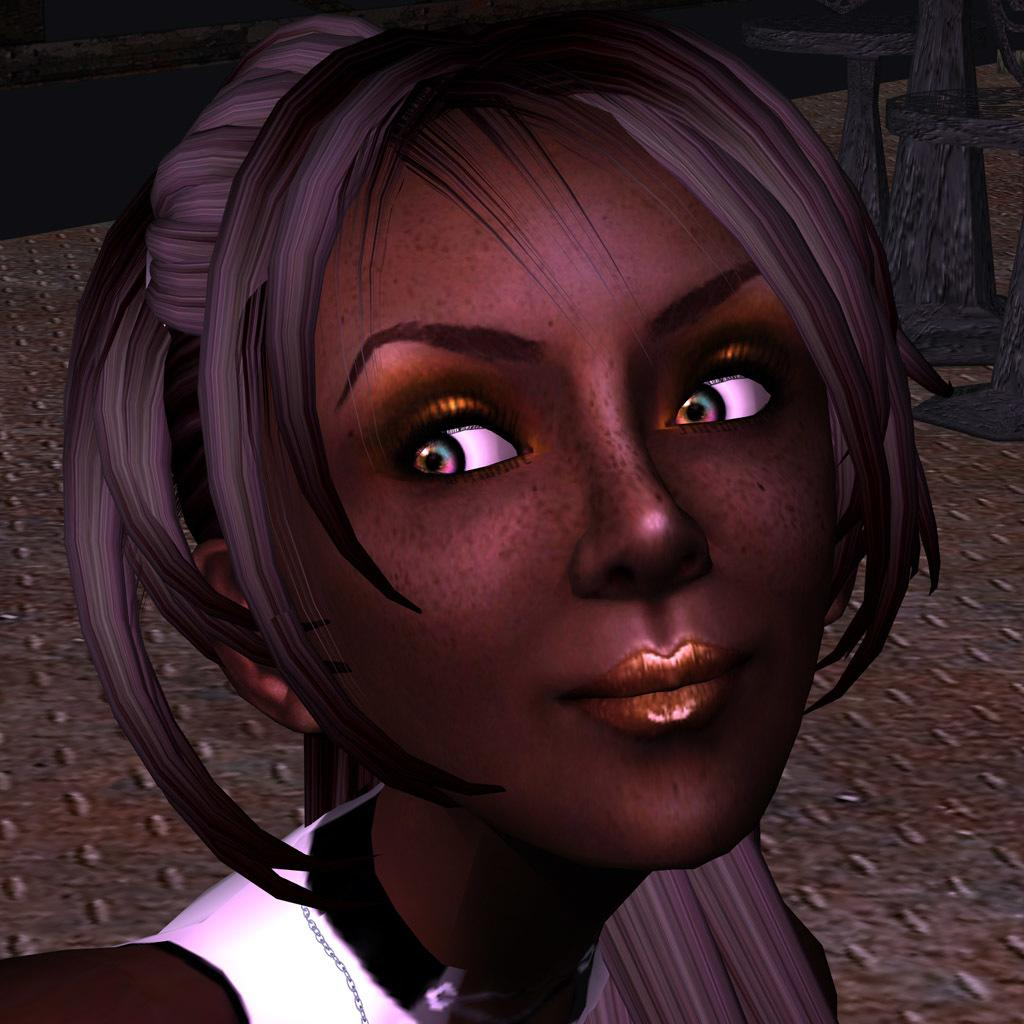What type of image is being described? The image is animated. Can you describe the main subject in the image? There is a woman in the image. What can be seen in the background of the image? There are objects in the background of the image. What type of clam can be seen in the image? There is no clam present in the image. Can you describe the cellar in the image? There is no cellar present in the image. 